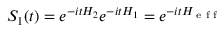Convert formula to latex. <formula><loc_0><loc_0><loc_500><loc_500>\begin{array} { r } { S _ { 1 } ( t ) = e ^ { - i t H _ { 2 } } e ^ { - i t H _ { 1 } } = e ^ { - i t H _ { e f f } } } \end{array}</formula> 